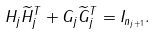Convert formula to latex. <formula><loc_0><loc_0><loc_500><loc_500>H _ { j } \widetilde { H } _ { j } ^ { T } + G _ { j } \widetilde { G } _ { j } ^ { T } = I _ { n _ { j + 1 } } .</formula> 